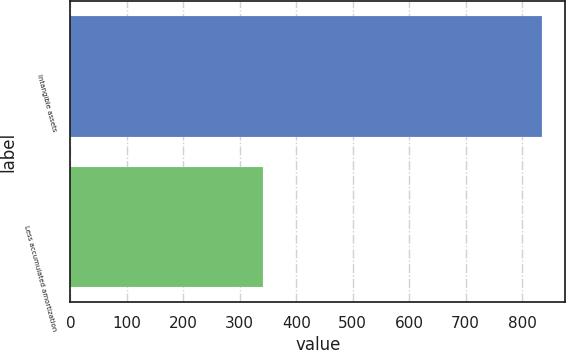Convert chart. <chart><loc_0><loc_0><loc_500><loc_500><bar_chart><fcel>Intangible assets<fcel>Less accumulated amortization<nl><fcel>835<fcel>342<nl></chart> 